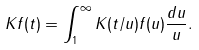<formula> <loc_0><loc_0><loc_500><loc_500>K f ( t ) = \int _ { 1 } ^ { \infty } K ( t / u ) f ( u ) \frac { d u } { u } .</formula> 